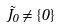Convert formula to latex. <formula><loc_0><loc_0><loc_500><loc_500>\tilde { J _ { 0 } } \neq \{ 0 \}</formula> 